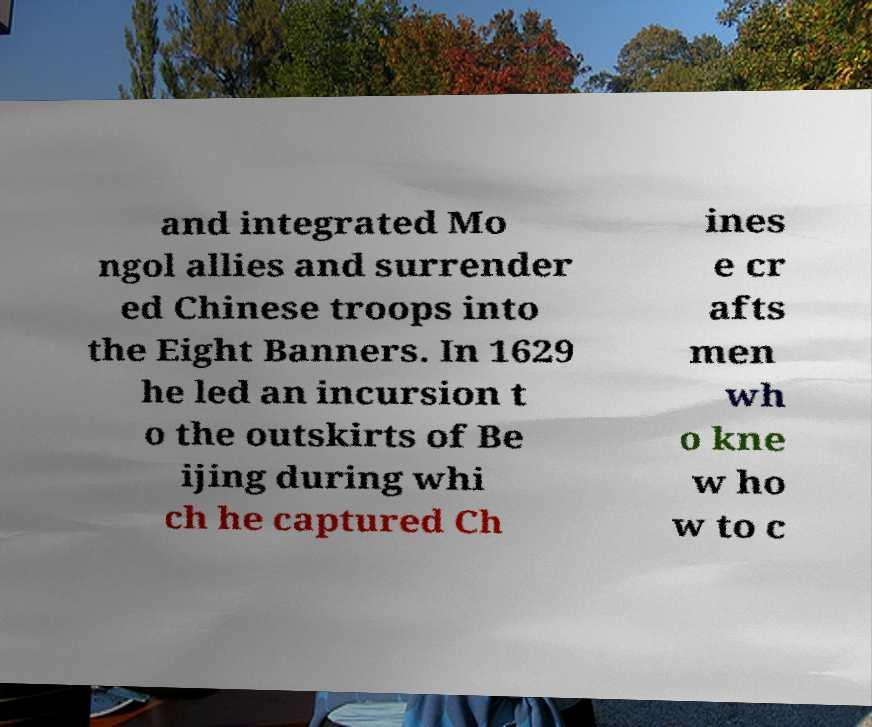There's text embedded in this image that I need extracted. Can you transcribe it verbatim? and integrated Mo ngol allies and surrender ed Chinese troops into the Eight Banners. In 1629 he led an incursion t o the outskirts of Be ijing during whi ch he captured Ch ines e cr afts men wh o kne w ho w to c 